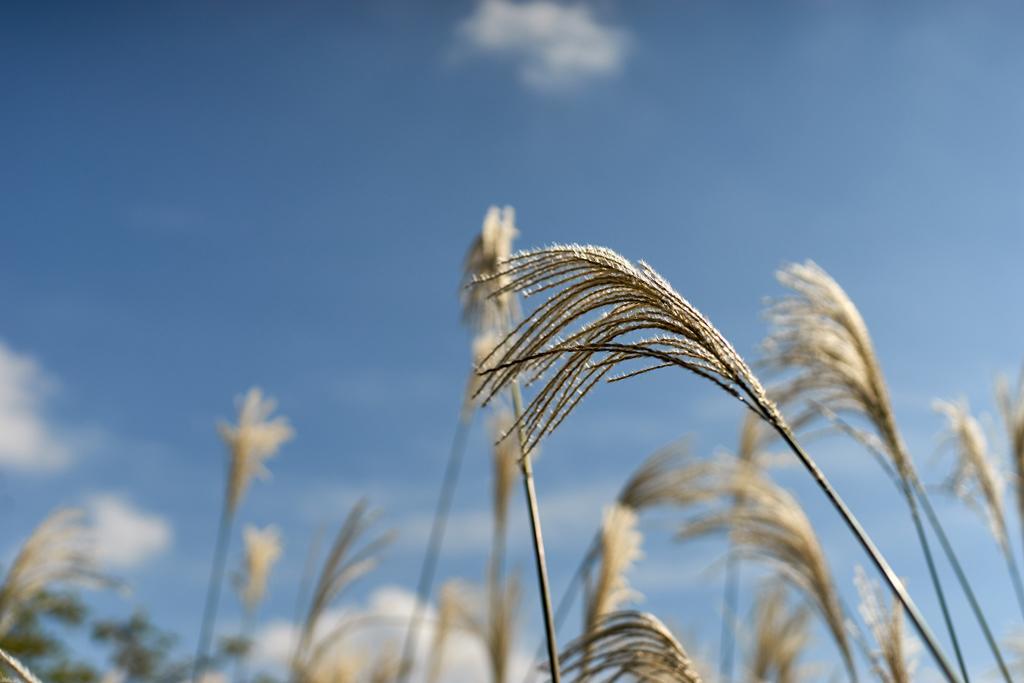Describe this image in one or two sentences. In this image we can see plants. In the background we can see plants at the bottom and there are clouds in the sky. 